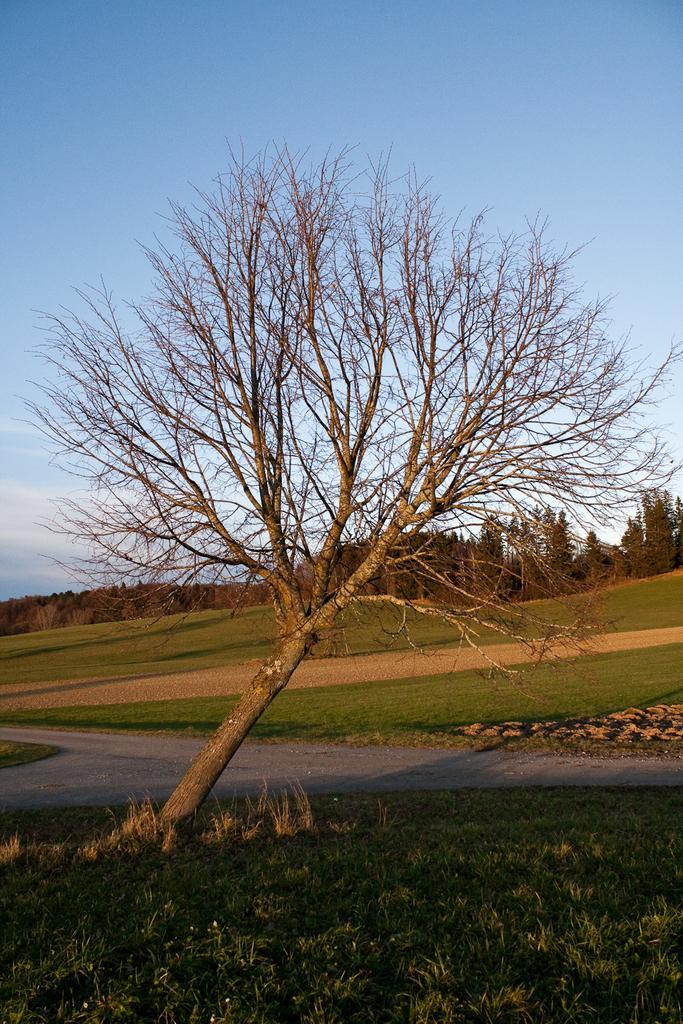In one or two sentences, can you explain what this image depicts? In this image I can see a dried tree. Background I can see grass and trees in green color and the sky is in blue and white color. 